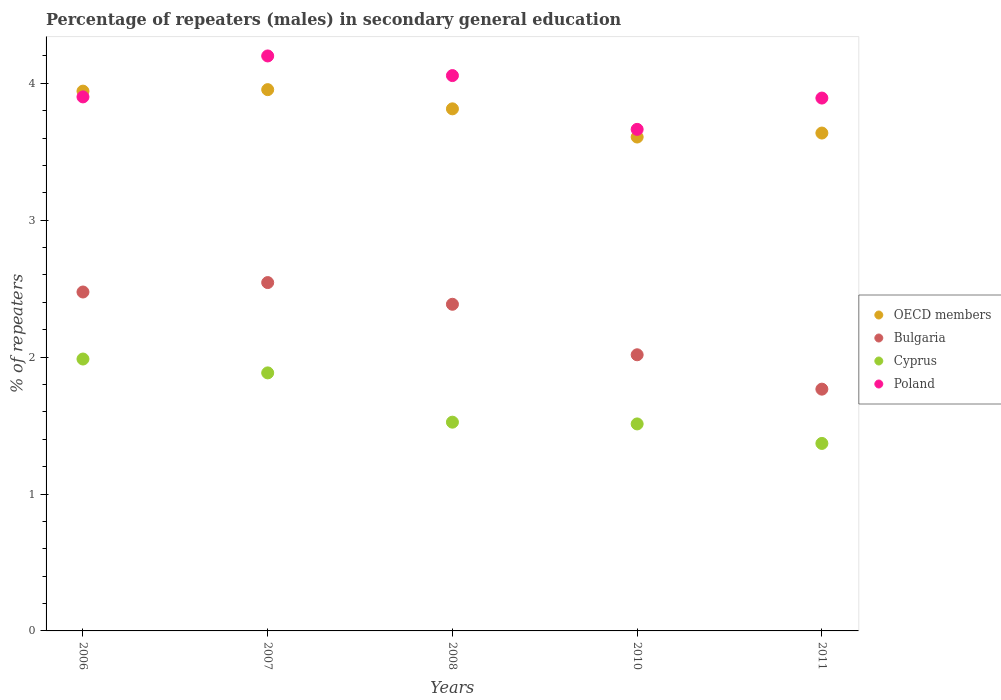How many different coloured dotlines are there?
Offer a terse response. 4. What is the percentage of male repeaters in Bulgaria in 2006?
Ensure brevity in your answer.  2.48. Across all years, what is the maximum percentage of male repeaters in OECD members?
Make the answer very short. 3.95. Across all years, what is the minimum percentage of male repeaters in Cyprus?
Ensure brevity in your answer.  1.37. What is the total percentage of male repeaters in Poland in the graph?
Offer a very short reply. 19.71. What is the difference between the percentage of male repeaters in Poland in 2007 and that in 2008?
Your response must be concise. 0.14. What is the difference between the percentage of male repeaters in Bulgaria in 2011 and the percentage of male repeaters in OECD members in 2008?
Ensure brevity in your answer.  -2.05. What is the average percentage of male repeaters in OECD members per year?
Provide a short and direct response. 3.79. In the year 2006, what is the difference between the percentage of male repeaters in Cyprus and percentage of male repeaters in Poland?
Your answer should be compact. -1.91. In how many years, is the percentage of male repeaters in Cyprus greater than 1.4 %?
Give a very brief answer. 4. What is the ratio of the percentage of male repeaters in Cyprus in 2008 to that in 2010?
Ensure brevity in your answer.  1.01. What is the difference between the highest and the second highest percentage of male repeaters in Cyprus?
Your response must be concise. 0.1. What is the difference between the highest and the lowest percentage of male repeaters in Cyprus?
Provide a short and direct response. 0.62. Is the sum of the percentage of male repeaters in Poland in 2008 and 2011 greater than the maximum percentage of male repeaters in Cyprus across all years?
Ensure brevity in your answer.  Yes. Does the percentage of male repeaters in Bulgaria monotonically increase over the years?
Your answer should be very brief. No. Is the percentage of male repeaters in OECD members strictly less than the percentage of male repeaters in Poland over the years?
Make the answer very short. No. How many years are there in the graph?
Give a very brief answer. 5. What is the difference between two consecutive major ticks on the Y-axis?
Ensure brevity in your answer.  1. Are the values on the major ticks of Y-axis written in scientific E-notation?
Ensure brevity in your answer.  No. Does the graph contain any zero values?
Give a very brief answer. No. Does the graph contain grids?
Offer a very short reply. No. How many legend labels are there?
Offer a very short reply. 4. What is the title of the graph?
Keep it short and to the point. Percentage of repeaters (males) in secondary general education. Does "High income" appear as one of the legend labels in the graph?
Ensure brevity in your answer.  No. What is the label or title of the X-axis?
Ensure brevity in your answer.  Years. What is the label or title of the Y-axis?
Give a very brief answer. % of repeaters. What is the % of repeaters in OECD members in 2006?
Your answer should be very brief. 3.94. What is the % of repeaters in Bulgaria in 2006?
Give a very brief answer. 2.48. What is the % of repeaters of Cyprus in 2006?
Make the answer very short. 1.99. What is the % of repeaters in Poland in 2006?
Give a very brief answer. 3.9. What is the % of repeaters of OECD members in 2007?
Your response must be concise. 3.95. What is the % of repeaters of Bulgaria in 2007?
Your answer should be compact. 2.54. What is the % of repeaters in Cyprus in 2007?
Provide a short and direct response. 1.88. What is the % of repeaters in Poland in 2007?
Your answer should be very brief. 4.2. What is the % of repeaters of OECD members in 2008?
Give a very brief answer. 3.81. What is the % of repeaters in Bulgaria in 2008?
Provide a short and direct response. 2.39. What is the % of repeaters in Cyprus in 2008?
Offer a terse response. 1.52. What is the % of repeaters of Poland in 2008?
Your answer should be compact. 4.06. What is the % of repeaters of OECD members in 2010?
Keep it short and to the point. 3.61. What is the % of repeaters of Bulgaria in 2010?
Offer a terse response. 2.02. What is the % of repeaters in Cyprus in 2010?
Your answer should be compact. 1.51. What is the % of repeaters of Poland in 2010?
Ensure brevity in your answer.  3.66. What is the % of repeaters in OECD members in 2011?
Your response must be concise. 3.64. What is the % of repeaters in Bulgaria in 2011?
Give a very brief answer. 1.77. What is the % of repeaters of Cyprus in 2011?
Offer a very short reply. 1.37. What is the % of repeaters in Poland in 2011?
Offer a very short reply. 3.89. Across all years, what is the maximum % of repeaters in OECD members?
Give a very brief answer. 3.95. Across all years, what is the maximum % of repeaters of Bulgaria?
Provide a short and direct response. 2.54. Across all years, what is the maximum % of repeaters in Cyprus?
Your response must be concise. 1.99. Across all years, what is the maximum % of repeaters in Poland?
Provide a succinct answer. 4.2. Across all years, what is the minimum % of repeaters in OECD members?
Provide a succinct answer. 3.61. Across all years, what is the minimum % of repeaters of Bulgaria?
Provide a short and direct response. 1.77. Across all years, what is the minimum % of repeaters in Cyprus?
Provide a succinct answer. 1.37. Across all years, what is the minimum % of repeaters of Poland?
Give a very brief answer. 3.66. What is the total % of repeaters of OECD members in the graph?
Keep it short and to the point. 18.95. What is the total % of repeaters of Bulgaria in the graph?
Offer a terse response. 11.19. What is the total % of repeaters in Cyprus in the graph?
Offer a terse response. 8.28. What is the total % of repeaters in Poland in the graph?
Your answer should be very brief. 19.71. What is the difference between the % of repeaters of OECD members in 2006 and that in 2007?
Your answer should be compact. -0.01. What is the difference between the % of repeaters in Bulgaria in 2006 and that in 2007?
Give a very brief answer. -0.07. What is the difference between the % of repeaters of Cyprus in 2006 and that in 2007?
Ensure brevity in your answer.  0.1. What is the difference between the % of repeaters in Poland in 2006 and that in 2007?
Your response must be concise. -0.3. What is the difference between the % of repeaters of OECD members in 2006 and that in 2008?
Your response must be concise. 0.13. What is the difference between the % of repeaters of Bulgaria in 2006 and that in 2008?
Your answer should be very brief. 0.09. What is the difference between the % of repeaters in Cyprus in 2006 and that in 2008?
Keep it short and to the point. 0.46. What is the difference between the % of repeaters in Poland in 2006 and that in 2008?
Your answer should be very brief. -0.16. What is the difference between the % of repeaters of OECD members in 2006 and that in 2010?
Keep it short and to the point. 0.34. What is the difference between the % of repeaters of Bulgaria in 2006 and that in 2010?
Ensure brevity in your answer.  0.46. What is the difference between the % of repeaters in Cyprus in 2006 and that in 2010?
Keep it short and to the point. 0.47. What is the difference between the % of repeaters in Poland in 2006 and that in 2010?
Provide a short and direct response. 0.24. What is the difference between the % of repeaters of OECD members in 2006 and that in 2011?
Give a very brief answer. 0.31. What is the difference between the % of repeaters in Bulgaria in 2006 and that in 2011?
Ensure brevity in your answer.  0.71. What is the difference between the % of repeaters in Cyprus in 2006 and that in 2011?
Your answer should be compact. 0.62. What is the difference between the % of repeaters in Poland in 2006 and that in 2011?
Offer a very short reply. 0.01. What is the difference between the % of repeaters of OECD members in 2007 and that in 2008?
Your answer should be very brief. 0.14. What is the difference between the % of repeaters in Bulgaria in 2007 and that in 2008?
Your response must be concise. 0.16. What is the difference between the % of repeaters in Cyprus in 2007 and that in 2008?
Your answer should be very brief. 0.36. What is the difference between the % of repeaters of Poland in 2007 and that in 2008?
Make the answer very short. 0.14. What is the difference between the % of repeaters of OECD members in 2007 and that in 2010?
Your response must be concise. 0.35. What is the difference between the % of repeaters of Bulgaria in 2007 and that in 2010?
Ensure brevity in your answer.  0.53. What is the difference between the % of repeaters in Cyprus in 2007 and that in 2010?
Provide a succinct answer. 0.37. What is the difference between the % of repeaters in Poland in 2007 and that in 2010?
Provide a short and direct response. 0.54. What is the difference between the % of repeaters of OECD members in 2007 and that in 2011?
Your answer should be compact. 0.32. What is the difference between the % of repeaters in Bulgaria in 2007 and that in 2011?
Provide a succinct answer. 0.78. What is the difference between the % of repeaters of Cyprus in 2007 and that in 2011?
Ensure brevity in your answer.  0.52. What is the difference between the % of repeaters of Poland in 2007 and that in 2011?
Provide a succinct answer. 0.31. What is the difference between the % of repeaters in OECD members in 2008 and that in 2010?
Your response must be concise. 0.21. What is the difference between the % of repeaters in Bulgaria in 2008 and that in 2010?
Your answer should be compact. 0.37. What is the difference between the % of repeaters in Cyprus in 2008 and that in 2010?
Ensure brevity in your answer.  0.01. What is the difference between the % of repeaters of Poland in 2008 and that in 2010?
Your response must be concise. 0.39. What is the difference between the % of repeaters in OECD members in 2008 and that in 2011?
Your response must be concise. 0.18. What is the difference between the % of repeaters in Bulgaria in 2008 and that in 2011?
Provide a short and direct response. 0.62. What is the difference between the % of repeaters of Cyprus in 2008 and that in 2011?
Ensure brevity in your answer.  0.16. What is the difference between the % of repeaters of Poland in 2008 and that in 2011?
Keep it short and to the point. 0.16. What is the difference between the % of repeaters in OECD members in 2010 and that in 2011?
Ensure brevity in your answer.  -0.03. What is the difference between the % of repeaters in Bulgaria in 2010 and that in 2011?
Your answer should be compact. 0.25. What is the difference between the % of repeaters of Cyprus in 2010 and that in 2011?
Make the answer very short. 0.14. What is the difference between the % of repeaters of Poland in 2010 and that in 2011?
Provide a short and direct response. -0.23. What is the difference between the % of repeaters in OECD members in 2006 and the % of repeaters in Bulgaria in 2007?
Give a very brief answer. 1.4. What is the difference between the % of repeaters of OECD members in 2006 and the % of repeaters of Cyprus in 2007?
Your answer should be very brief. 2.06. What is the difference between the % of repeaters of OECD members in 2006 and the % of repeaters of Poland in 2007?
Make the answer very short. -0.26. What is the difference between the % of repeaters of Bulgaria in 2006 and the % of repeaters of Cyprus in 2007?
Your response must be concise. 0.59. What is the difference between the % of repeaters in Bulgaria in 2006 and the % of repeaters in Poland in 2007?
Offer a very short reply. -1.72. What is the difference between the % of repeaters in Cyprus in 2006 and the % of repeaters in Poland in 2007?
Make the answer very short. -2.21. What is the difference between the % of repeaters of OECD members in 2006 and the % of repeaters of Bulgaria in 2008?
Offer a very short reply. 1.56. What is the difference between the % of repeaters in OECD members in 2006 and the % of repeaters in Cyprus in 2008?
Your answer should be very brief. 2.42. What is the difference between the % of repeaters in OECD members in 2006 and the % of repeaters in Poland in 2008?
Offer a terse response. -0.11. What is the difference between the % of repeaters in Bulgaria in 2006 and the % of repeaters in Cyprus in 2008?
Your answer should be very brief. 0.95. What is the difference between the % of repeaters in Bulgaria in 2006 and the % of repeaters in Poland in 2008?
Your answer should be very brief. -1.58. What is the difference between the % of repeaters in Cyprus in 2006 and the % of repeaters in Poland in 2008?
Provide a short and direct response. -2.07. What is the difference between the % of repeaters in OECD members in 2006 and the % of repeaters in Bulgaria in 2010?
Provide a succinct answer. 1.93. What is the difference between the % of repeaters in OECD members in 2006 and the % of repeaters in Cyprus in 2010?
Keep it short and to the point. 2.43. What is the difference between the % of repeaters in OECD members in 2006 and the % of repeaters in Poland in 2010?
Your answer should be very brief. 0.28. What is the difference between the % of repeaters of Bulgaria in 2006 and the % of repeaters of Cyprus in 2010?
Your answer should be very brief. 0.96. What is the difference between the % of repeaters of Bulgaria in 2006 and the % of repeaters of Poland in 2010?
Offer a terse response. -1.19. What is the difference between the % of repeaters of Cyprus in 2006 and the % of repeaters of Poland in 2010?
Keep it short and to the point. -1.68. What is the difference between the % of repeaters of OECD members in 2006 and the % of repeaters of Bulgaria in 2011?
Offer a terse response. 2.18. What is the difference between the % of repeaters in OECD members in 2006 and the % of repeaters in Cyprus in 2011?
Provide a short and direct response. 2.57. What is the difference between the % of repeaters of OECD members in 2006 and the % of repeaters of Poland in 2011?
Offer a very short reply. 0.05. What is the difference between the % of repeaters of Bulgaria in 2006 and the % of repeaters of Cyprus in 2011?
Provide a succinct answer. 1.11. What is the difference between the % of repeaters of Bulgaria in 2006 and the % of repeaters of Poland in 2011?
Your answer should be very brief. -1.42. What is the difference between the % of repeaters in Cyprus in 2006 and the % of repeaters in Poland in 2011?
Your answer should be very brief. -1.91. What is the difference between the % of repeaters in OECD members in 2007 and the % of repeaters in Bulgaria in 2008?
Give a very brief answer. 1.57. What is the difference between the % of repeaters in OECD members in 2007 and the % of repeaters in Cyprus in 2008?
Your answer should be compact. 2.43. What is the difference between the % of repeaters in OECD members in 2007 and the % of repeaters in Poland in 2008?
Provide a succinct answer. -0.1. What is the difference between the % of repeaters of Bulgaria in 2007 and the % of repeaters of Cyprus in 2008?
Offer a terse response. 1.02. What is the difference between the % of repeaters of Bulgaria in 2007 and the % of repeaters of Poland in 2008?
Keep it short and to the point. -1.51. What is the difference between the % of repeaters of Cyprus in 2007 and the % of repeaters of Poland in 2008?
Provide a short and direct response. -2.17. What is the difference between the % of repeaters in OECD members in 2007 and the % of repeaters in Bulgaria in 2010?
Offer a very short reply. 1.94. What is the difference between the % of repeaters of OECD members in 2007 and the % of repeaters of Cyprus in 2010?
Provide a succinct answer. 2.44. What is the difference between the % of repeaters of OECD members in 2007 and the % of repeaters of Poland in 2010?
Your answer should be compact. 0.29. What is the difference between the % of repeaters in Bulgaria in 2007 and the % of repeaters in Cyprus in 2010?
Provide a succinct answer. 1.03. What is the difference between the % of repeaters in Bulgaria in 2007 and the % of repeaters in Poland in 2010?
Your response must be concise. -1.12. What is the difference between the % of repeaters in Cyprus in 2007 and the % of repeaters in Poland in 2010?
Keep it short and to the point. -1.78. What is the difference between the % of repeaters of OECD members in 2007 and the % of repeaters of Bulgaria in 2011?
Give a very brief answer. 2.19. What is the difference between the % of repeaters in OECD members in 2007 and the % of repeaters in Cyprus in 2011?
Your answer should be compact. 2.58. What is the difference between the % of repeaters of OECD members in 2007 and the % of repeaters of Poland in 2011?
Your answer should be compact. 0.06. What is the difference between the % of repeaters of Bulgaria in 2007 and the % of repeaters of Cyprus in 2011?
Provide a succinct answer. 1.18. What is the difference between the % of repeaters of Bulgaria in 2007 and the % of repeaters of Poland in 2011?
Your answer should be compact. -1.35. What is the difference between the % of repeaters in Cyprus in 2007 and the % of repeaters in Poland in 2011?
Your response must be concise. -2.01. What is the difference between the % of repeaters of OECD members in 2008 and the % of repeaters of Bulgaria in 2010?
Provide a succinct answer. 1.8. What is the difference between the % of repeaters in OECD members in 2008 and the % of repeaters in Cyprus in 2010?
Your answer should be very brief. 2.3. What is the difference between the % of repeaters of OECD members in 2008 and the % of repeaters of Poland in 2010?
Keep it short and to the point. 0.15. What is the difference between the % of repeaters of Bulgaria in 2008 and the % of repeaters of Cyprus in 2010?
Give a very brief answer. 0.87. What is the difference between the % of repeaters of Bulgaria in 2008 and the % of repeaters of Poland in 2010?
Offer a very short reply. -1.28. What is the difference between the % of repeaters of Cyprus in 2008 and the % of repeaters of Poland in 2010?
Your response must be concise. -2.14. What is the difference between the % of repeaters in OECD members in 2008 and the % of repeaters in Bulgaria in 2011?
Ensure brevity in your answer.  2.05. What is the difference between the % of repeaters in OECD members in 2008 and the % of repeaters in Cyprus in 2011?
Offer a terse response. 2.44. What is the difference between the % of repeaters of OECD members in 2008 and the % of repeaters of Poland in 2011?
Keep it short and to the point. -0.08. What is the difference between the % of repeaters of Bulgaria in 2008 and the % of repeaters of Cyprus in 2011?
Make the answer very short. 1.02. What is the difference between the % of repeaters in Bulgaria in 2008 and the % of repeaters in Poland in 2011?
Provide a succinct answer. -1.51. What is the difference between the % of repeaters in Cyprus in 2008 and the % of repeaters in Poland in 2011?
Offer a very short reply. -2.37. What is the difference between the % of repeaters of OECD members in 2010 and the % of repeaters of Bulgaria in 2011?
Your answer should be compact. 1.84. What is the difference between the % of repeaters in OECD members in 2010 and the % of repeaters in Cyprus in 2011?
Your response must be concise. 2.24. What is the difference between the % of repeaters of OECD members in 2010 and the % of repeaters of Poland in 2011?
Provide a succinct answer. -0.28. What is the difference between the % of repeaters of Bulgaria in 2010 and the % of repeaters of Cyprus in 2011?
Offer a terse response. 0.65. What is the difference between the % of repeaters in Bulgaria in 2010 and the % of repeaters in Poland in 2011?
Offer a terse response. -1.88. What is the difference between the % of repeaters of Cyprus in 2010 and the % of repeaters of Poland in 2011?
Give a very brief answer. -2.38. What is the average % of repeaters of OECD members per year?
Your answer should be very brief. 3.79. What is the average % of repeaters in Bulgaria per year?
Your response must be concise. 2.24. What is the average % of repeaters of Cyprus per year?
Your answer should be very brief. 1.66. What is the average % of repeaters of Poland per year?
Provide a succinct answer. 3.94. In the year 2006, what is the difference between the % of repeaters of OECD members and % of repeaters of Bulgaria?
Offer a terse response. 1.47. In the year 2006, what is the difference between the % of repeaters in OECD members and % of repeaters in Cyprus?
Keep it short and to the point. 1.96. In the year 2006, what is the difference between the % of repeaters in OECD members and % of repeaters in Poland?
Your response must be concise. 0.04. In the year 2006, what is the difference between the % of repeaters of Bulgaria and % of repeaters of Cyprus?
Provide a succinct answer. 0.49. In the year 2006, what is the difference between the % of repeaters of Bulgaria and % of repeaters of Poland?
Your response must be concise. -1.43. In the year 2006, what is the difference between the % of repeaters in Cyprus and % of repeaters in Poland?
Give a very brief answer. -1.91. In the year 2007, what is the difference between the % of repeaters of OECD members and % of repeaters of Bulgaria?
Ensure brevity in your answer.  1.41. In the year 2007, what is the difference between the % of repeaters in OECD members and % of repeaters in Cyprus?
Your response must be concise. 2.07. In the year 2007, what is the difference between the % of repeaters in OECD members and % of repeaters in Poland?
Your response must be concise. -0.25. In the year 2007, what is the difference between the % of repeaters in Bulgaria and % of repeaters in Cyprus?
Make the answer very short. 0.66. In the year 2007, what is the difference between the % of repeaters of Bulgaria and % of repeaters of Poland?
Provide a short and direct response. -1.66. In the year 2007, what is the difference between the % of repeaters in Cyprus and % of repeaters in Poland?
Make the answer very short. -2.32. In the year 2008, what is the difference between the % of repeaters in OECD members and % of repeaters in Bulgaria?
Offer a terse response. 1.43. In the year 2008, what is the difference between the % of repeaters of OECD members and % of repeaters of Cyprus?
Your answer should be compact. 2.29. In the year 2008, what is the difference between the % of repeaters in OECD members and % of repeaters in Poland?
Offer a very short reply. -0.24. In the year 2008, what is the difference between the % of repeaters of Bulgaria and % of repeaters of Cyprus?
Give a very brief answer. 0.86. In the year 2008, what is the difference between the % of repeaters in Bulgaria and % of repeaters in Poland?
Your answer should be compact. -1.67. In the year 2008, what is the difference between the % of repeaters of Cyprus and % of repeaters of Poland?
Ensure brevity in your answer.  -2.53. In the year 2010, what is the difference between the % of repeaters of OECD members and % of repeaters of Bulgaria?
Ensure brevity in your answer.  1.59. In the year 2010, what is the difference between the % of repeaters in OECD members and % of repeaters in Cyprus?
Provide a succinct answer. 2.1. In the year 2010, what is the difference between the % of repeaters of OECD members and % of repeaters of Poland?
Your answer should be very brief. -0.06. In the year 2010, what is the difference between the % of repeaters of Bulgaria and % of repeaters of Cyprus?
Give a very brief answer. 0.51. In the year 2010, what is the difference between the % of repeaters of Bulgaria and % of repeaters of Poland?
Make the answer very short. -1.65. In the year 2010, what is the difference between the % of repeaters of Cyprus and % of repeaters of Poland?
Offer a very short reply. -2.15. In the year 2011, what is the difference between the % of repeaters in OECD members and % of repeaters in Bulgaria?
Give a very brief answer. 1.87. In the year 2011, what is the difference between the % of repeaters of OECD members and % of repeaters of Cyprus?
Offer a very short reply. 2.27. In the year 2011, what is the difference between the % of repeaters of OECD members and % of repeaters of Poland?
Your answer should be compact. -0.26. In the year 2011, what is the difference between the % of repeaters in Bulgaria and % of repeaters in Cyprus?
Give a very brief answer. 0.4. In the year 2011, what is the difference between the % of repeaters in Bulgaria and % of repeaters in Poland?
Make the answer very short. -2.13. In the year 2011, what is the difference between the % of repeaters of Cyprus and % of repeaters of Poland?
Make the answer very short. -2.52. What is the ratio of the % of repeaters of OECD members in 2006 to that in 2007?
Offer a very short reply. 1. What is the ratio of the % of repeaters in Bulgaria in 2006 to that in 2007?
Your answer should be very brief. 0.97. What is the ratio of the % of repeaters of Cyprus in 2006 to that in 2007?
Provide a short and direct response. 1.05. What is the ratio of the % of repeaters of Poland in 2006 to that in 2007?
Offer a terse response. 0.93. What is the ratio of the % of repeaters in OECD members in 2006 to that in 2008?
Offer a very short reply. 1.03. What is the ratio of the % of repeaters of Bulgaria in 2006 to that in 2008?
Offer a terse response. 1.04. What is the ratio of the % of repeaters of Cyprus in 2006 to that in 2008?
Offer a very short reply. 1.3. What is the ratio of the % of repeaters of Poland in 2006 to that in 2008?
Offer a very short reply. 0.96. What is the ratio of the % of repeaters of OECD members in 2006 to that in 2010?
Offer a terse response. 1.09. What is the ratio of the % of repeaters of Bulgaria in 2006 to that in 2010?
Your response must be concise. 1.23. What is the ratio of the % of repeaters of Cyprus in 2006 to that in 2010?
Offer a terse response. 1.31. What is the ratio of the % of repeaters of Poland in 2006 to that in 2010?
Provide a short and direct response. 1.06. What is the ratio of the % of repeaters of OECD members in 2006 to that in 2011?
Provide a short and direct response. 1.08. What is the ratio of the % of repeaters of Bulgaria in 2006 to that in 2011?
Your response must be concise. 1.4. What is the ratio of the % of repeaters of Cyprus in 2006 to that in 2011?
Make the answer very short. 1.45. What is the ratio of the % of repeaters of OECD members in 2007 to that in 2008?
Ensure brevity in your answer.  1.04. What is the ratio of the % of repeaters of Bulgaria in 2007 to that in 2008?
Offer a very short reply. 1.07. What is the ratio of the % of repeaters in Cyprus in 2007 to that in 2008?
Your answer should be compact. 1.24. What is the ratio of the % of repeaters in Poland in 2007 to that in 2008?
Provide a succinct answer. 1.04. What is the ratio of the % of repeaters of OECD members in 2007 to that in 2010?
Provide a short and direct response. 1.1. What is the ratio of the % of repeaters of Bulgaria in 2007 to that in 2010?
Your answer should be very brief. 1.26. What is the ratio of the % of repeaters in Cyprus in 2007 to that in 2010?
Offer a very short reply. 1.25. What is the ratio of the % of repeaters of Poland in 2007 to that in 2010?
Your answer should be compact. 1.15. What is the ratio of the % of repeaters of OECD members in 2007 to that in 2011?
Your answer should be compact. 1.09. What is the ratio of the % of repeaters of Bulgaria in 2007 to that in 2011?
Offer a terse response. 1.44. What is the ratio of the % of repeaters of Cyprus in 2007 to that in 2011?
Provide a short and direct response. 1.38. What is the ratio of the % of repeaters in Poland in 2007 to that in 2011?
Provide a succinct answer. 1.08. What is the ratio of the % of repeaters in OECD members in 2008 to that in 2010?
Offer a very short reply. 1.06. What is the ratio of the % of repeaters in Bulgaria in 2008 to that in 2010?
Give a very brief answer. 1.18. What is the ratio of the % of repeaters of Cyprus in 2008 to that in 2010?
Provide a short and direct response. 1.01. What is the ratio of the % of repeaters in Poland in 2008 to that in 2010?
Ensure brevity in your answer.  1.11. What is the ratio of the % of repeaters of OECD members in 2008 to that in 2011?
Keep it short and to the point. 1.05. What is the ratio of the % of repeaters of Bulgaria in 2008 to that in 2011?
Offer a very short reply. 1.35. What is the ratio of the % of repeaters of Cyprus in 2008 to that in 2011?
Your answer should be compact. 1.11. What is the ratio of the % of repeaters of Poland in 2008 to that in 2011?
Offer a terse response. 1.04. What is the ratio of the % of repeaters in OECD members in 2010 to that in 2011?
Your answer should be compact. 0.99. What is the ratio of the % of repeaters of Bulgaria in 2010 to that in 2011?
Give a very brief answer. 1.14. What is the ratio of the % of repeaters of Cyprus in 2010 to that in 2011?
Ensure brevity in your answer.  1.1. What is the ratio of the % of repeaters in Poland in 2010 to that in 2011?
Provide a succinct answer. 0.94. What is the difference between the highest and the second highest % of repeaters of OECD members?
Ensure brevity in your answer.  0.01. What is the difference between the highest and the second highest % of repeaters in Bulgaria?
Keep it short and to the point. 0.07. What is the difference between the highest and the second highest % of repeaters in Cyprus?
Provide a succinct answer. 0.1. What is the difference between the highest and the second highest % of repeaters of Poland?
Provide a short and direct response. 0.14. What is the difference between the highest and the lowest % of repeaters of OECD members?
Keep it short and to the point. 0.35. What is the difference between the highest and the lowest % of repeaters in Bulgaria?
Ensure brevity in your answer.  0.78. What is the difference between the highest and the lowest % of repeaters in Cyprus?
Your response must be concise. 0.62. What is the difference between the highest and the lowest % of repeaters of Poland?
Your answer should be compact. 0.54. 